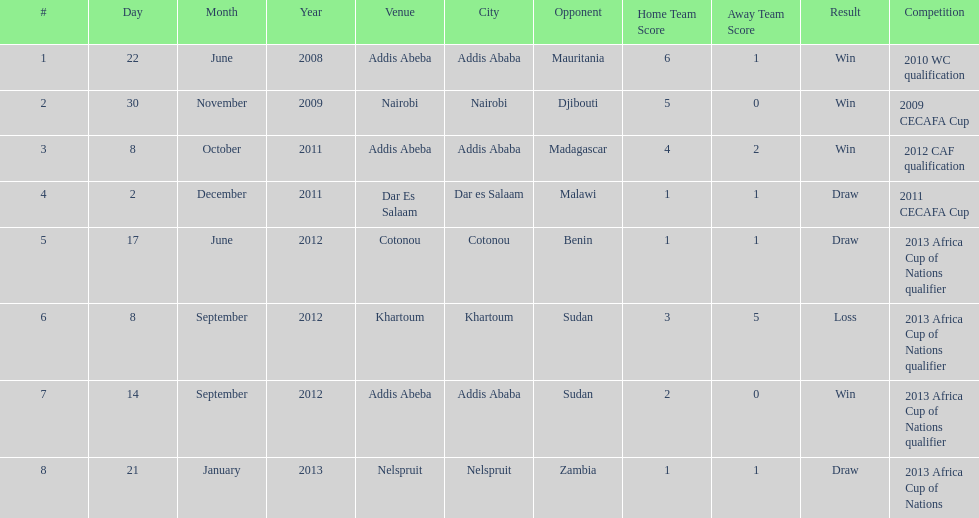True or false? in comparison, the ethiopian national team has more draws than wins. False. 